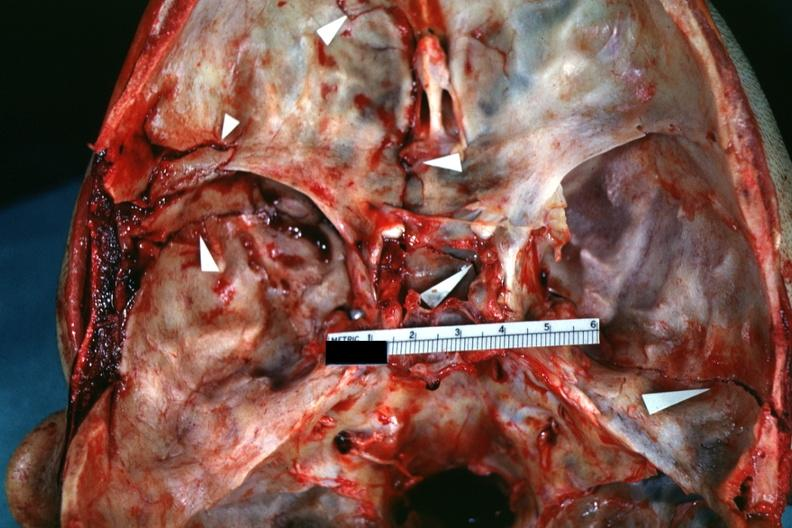what is present?
Answer the question using a single word or phrase. Basilar skull fracture 